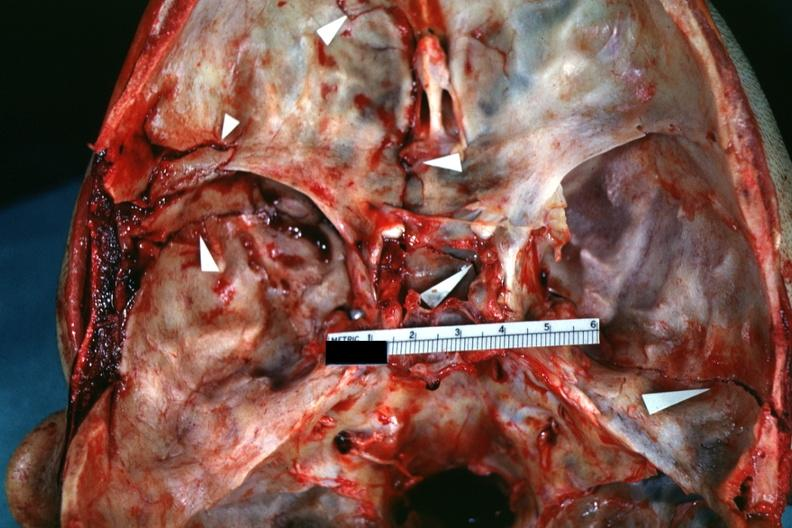what is present?
Answer the question using a single word or phrase. Basilar skull fracture 